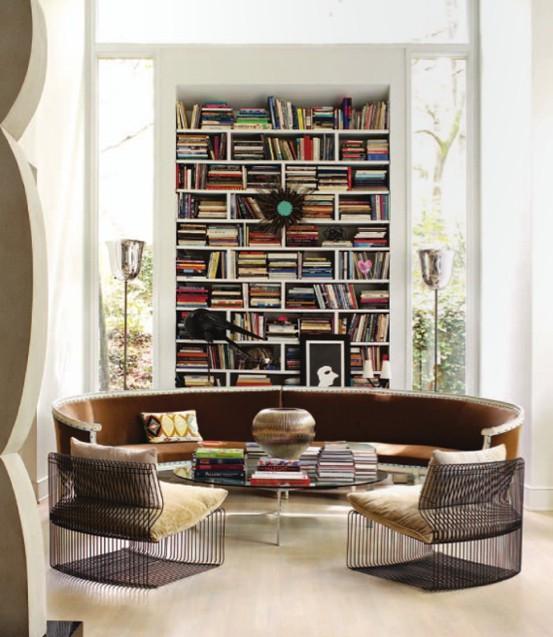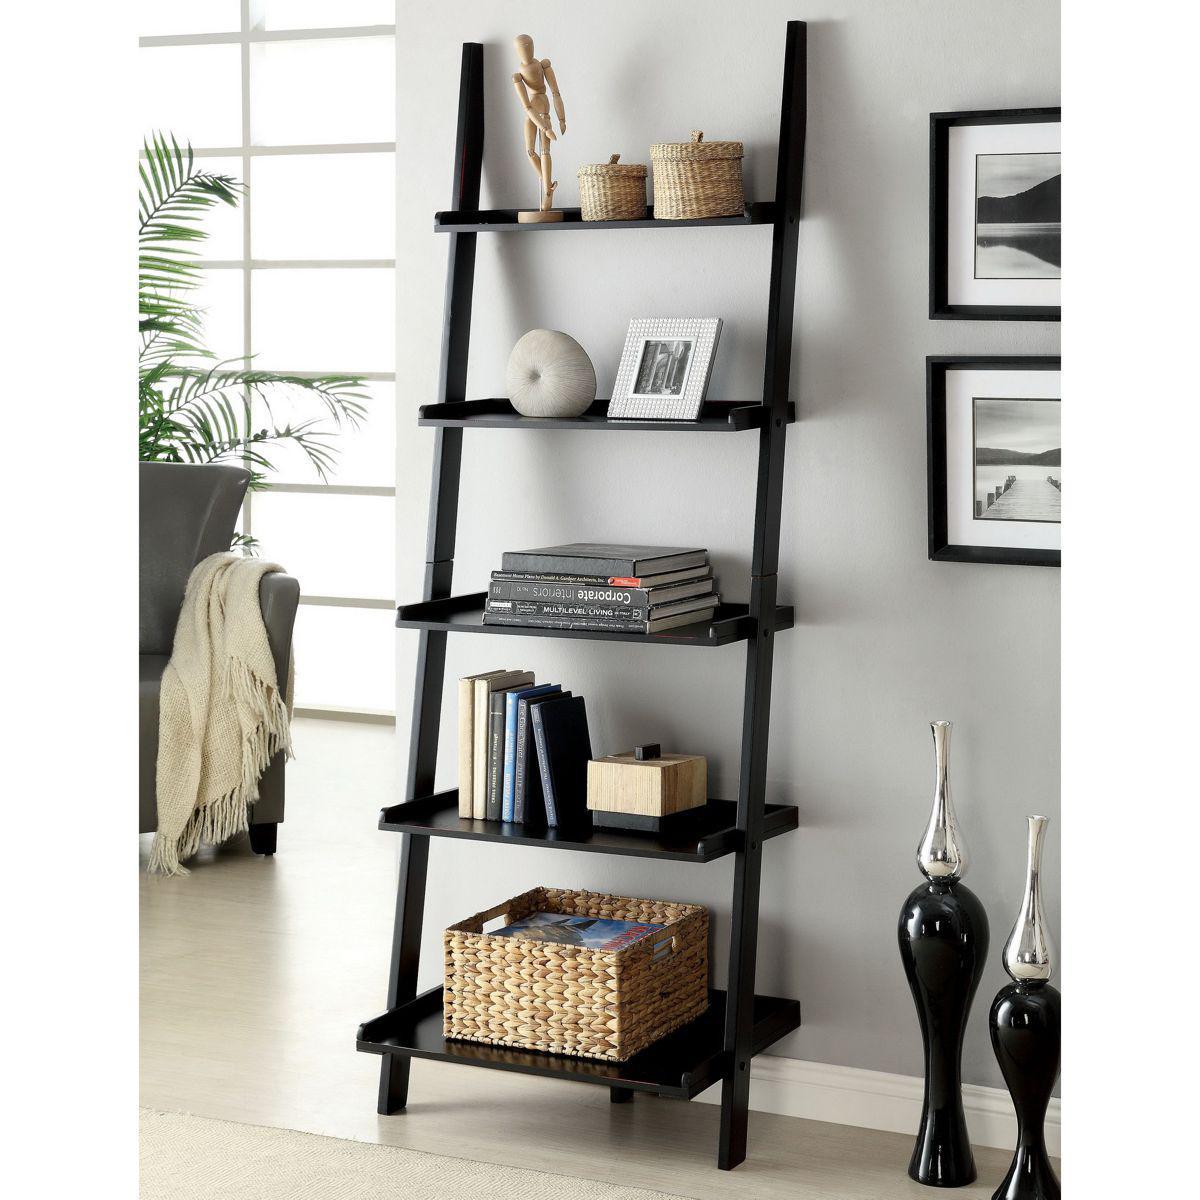The first image is the image on the left, the second image is the image on the right. Evaluate the accuracy of this statement regarding the images: "there is a white built in bookshelf with a sofa , two chairs and a coffee table in front of it". Is it true? Answer yes or no. Yes. 